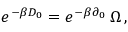Convert formula to latex. <formula><loc_0><loc_0><loc_500><loc_500>e ^ { - \beta D _ { 0 } } = e ^ { - \beta \partial _ { 0 } } \, \Omega \, ,</formula> 